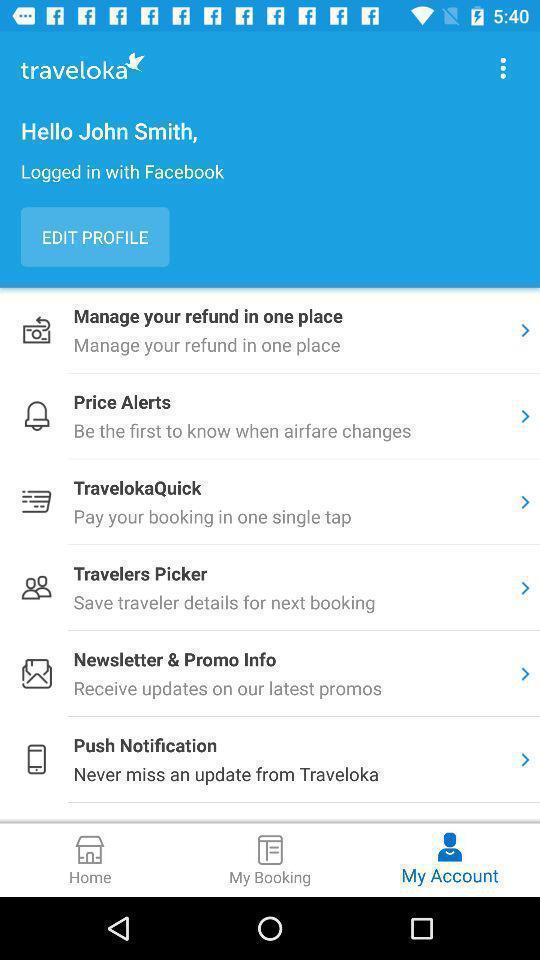What details can you identify in this image? Screen displaying user information and multiple options. 